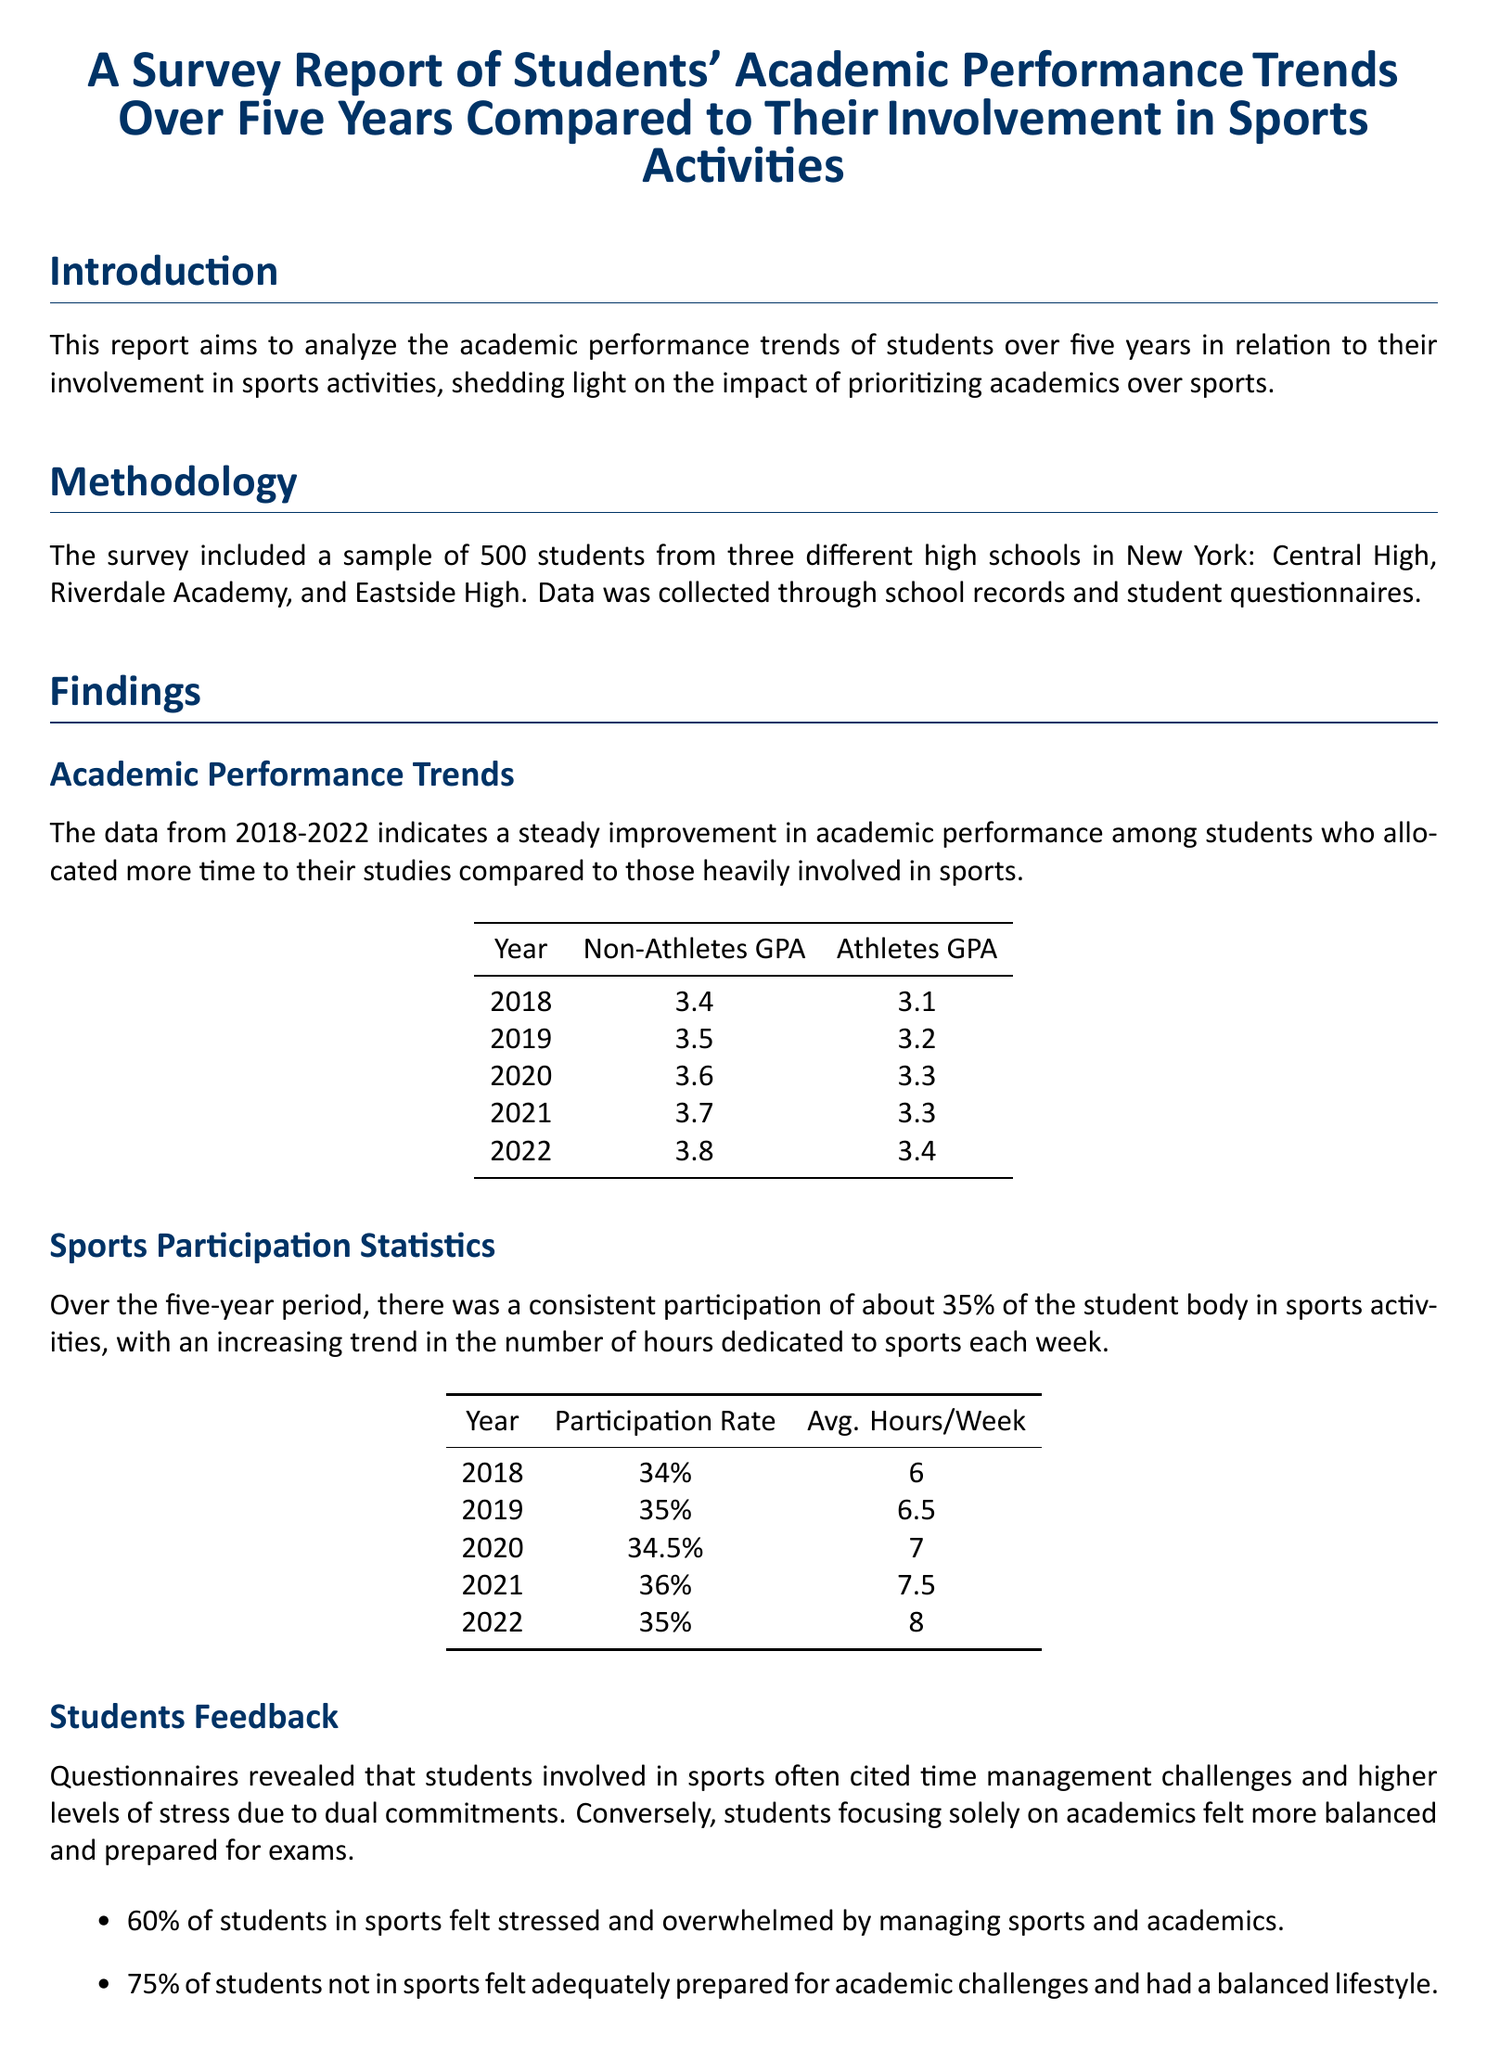What was the GPA of non-athletes in 2020? The GPA of non-athletes in 2020 is specifically listed in the findings table.
Answer: 3.6 What year had the highest GPA for athletes? The data shows the GPA trends for athletes over the years, indicating the highest value among them.
Answer: 2022 What percentage of students participated in sports in 2019? The participation rate for sports is detailed in the statistics table for each year, with 2019 being one of them.
Answer: 35% What was the average hours per week dedicated to sports in 2021? The entry for 2021 in the sports participation statistics table contains this specific detail.
Answer: 7.5 What percentage of students not in sports felt adequately prepared for academic challenges? The findings on student feedback reveal this percentage from the questionnaire responses.
Answer: 75% In which year did non-athletes outperform athletes in GPA by the largest margin? Calculating from the GPA trends table, this year shows the greatest difference between non-athletes and athletes.
Answer: 2018 What was a common feedback from students involved in sports? The report summarized student feedback highlighting specific sentiments from athletes.
Answer: Time management challenges Which high school had students surveyed? The introduction lists the names of the high schools from which the survey sample was taken.
Answer: Central High, Riverdale Academy, and Eastside High 